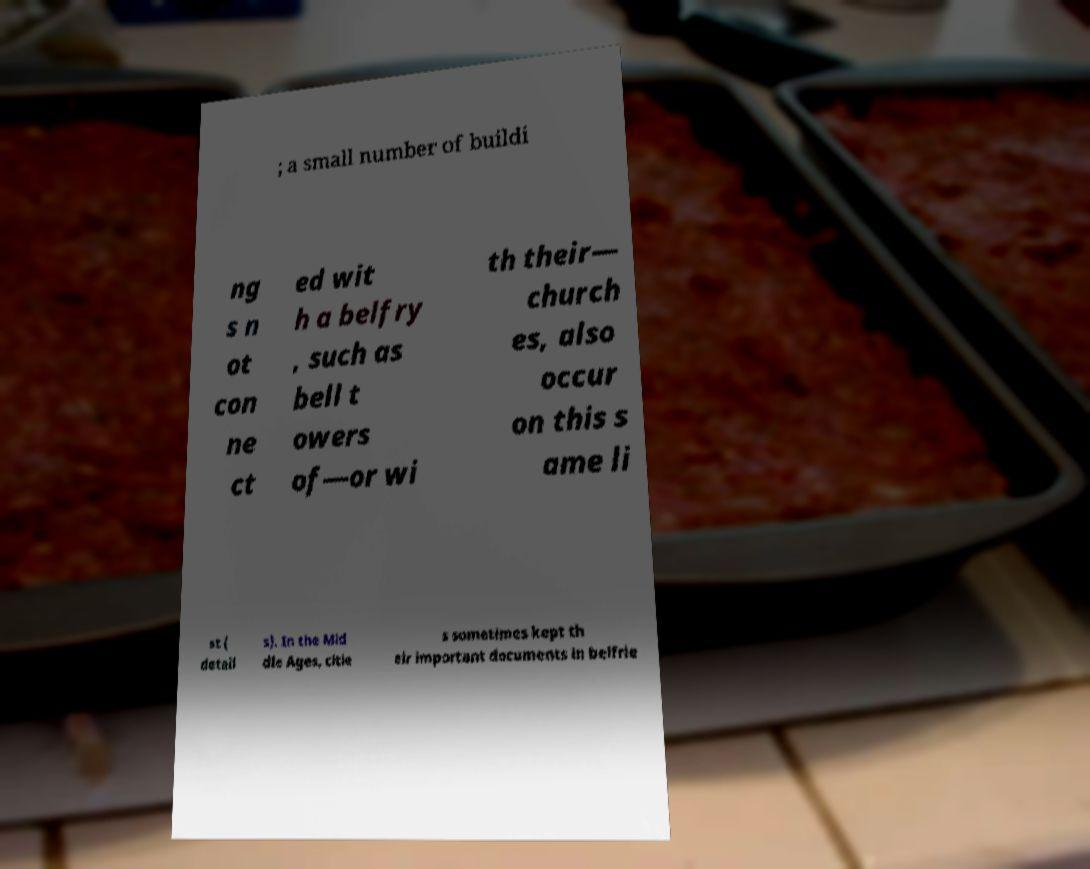For documentation purposes, I need the text within this image transcribed. Could you provide that? ; a small number of buildi ng s n ot con ne ct ed wit h a belfry , such as bell t owers of—or wi th their— church es, also occur on this s ame li st ( detail s). In the Mid dle Ages, citie s sometimes kept th eir important documents in belfrie 